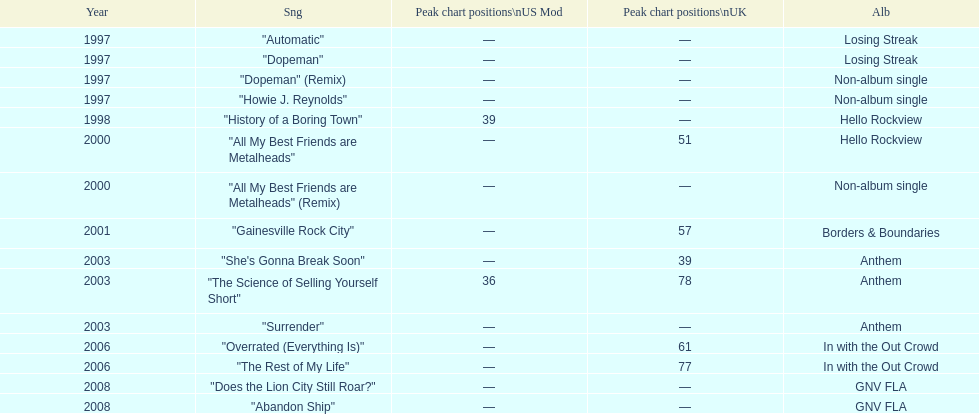What was the first single to earn a chart position? "History of a Boring Town". 